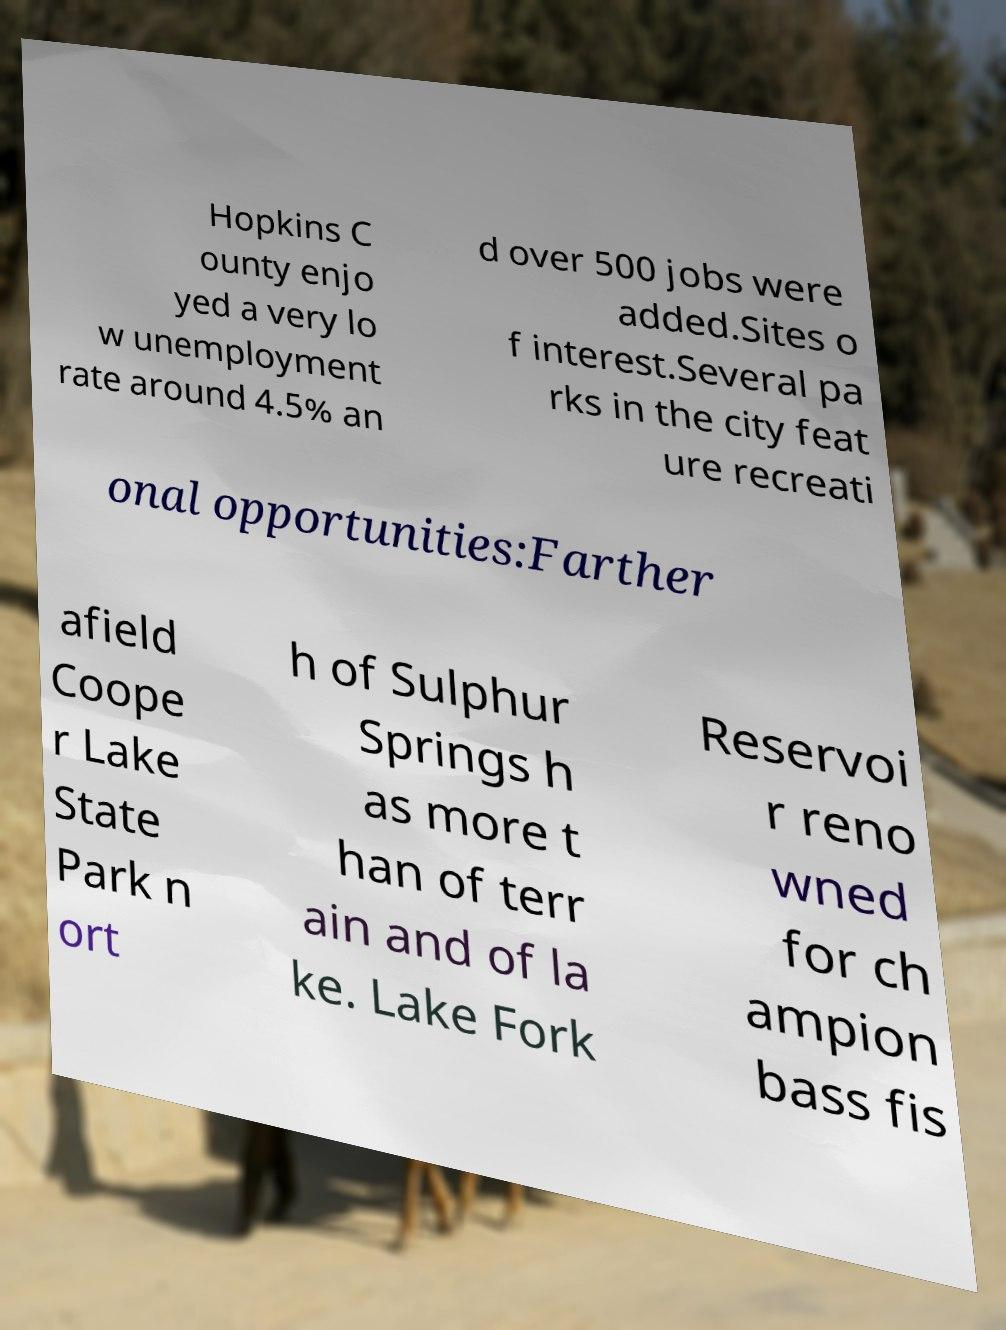What messages or text are displayed in this image? I need them in a readable, typed format. Hopkins C ounty enjo yed a very lo w unemployment rate around 4.5% an d over 500 jobs were added.Sites o f interest.Several pa rks in the city feat ure recreati onal opportunities:Farther afield Coope r Lake State Park n ort h of Sulphur Springs h as more t han of terr ain and of la ke. Lake Fork Reservoi r reno wned for ch ampion bass fis 